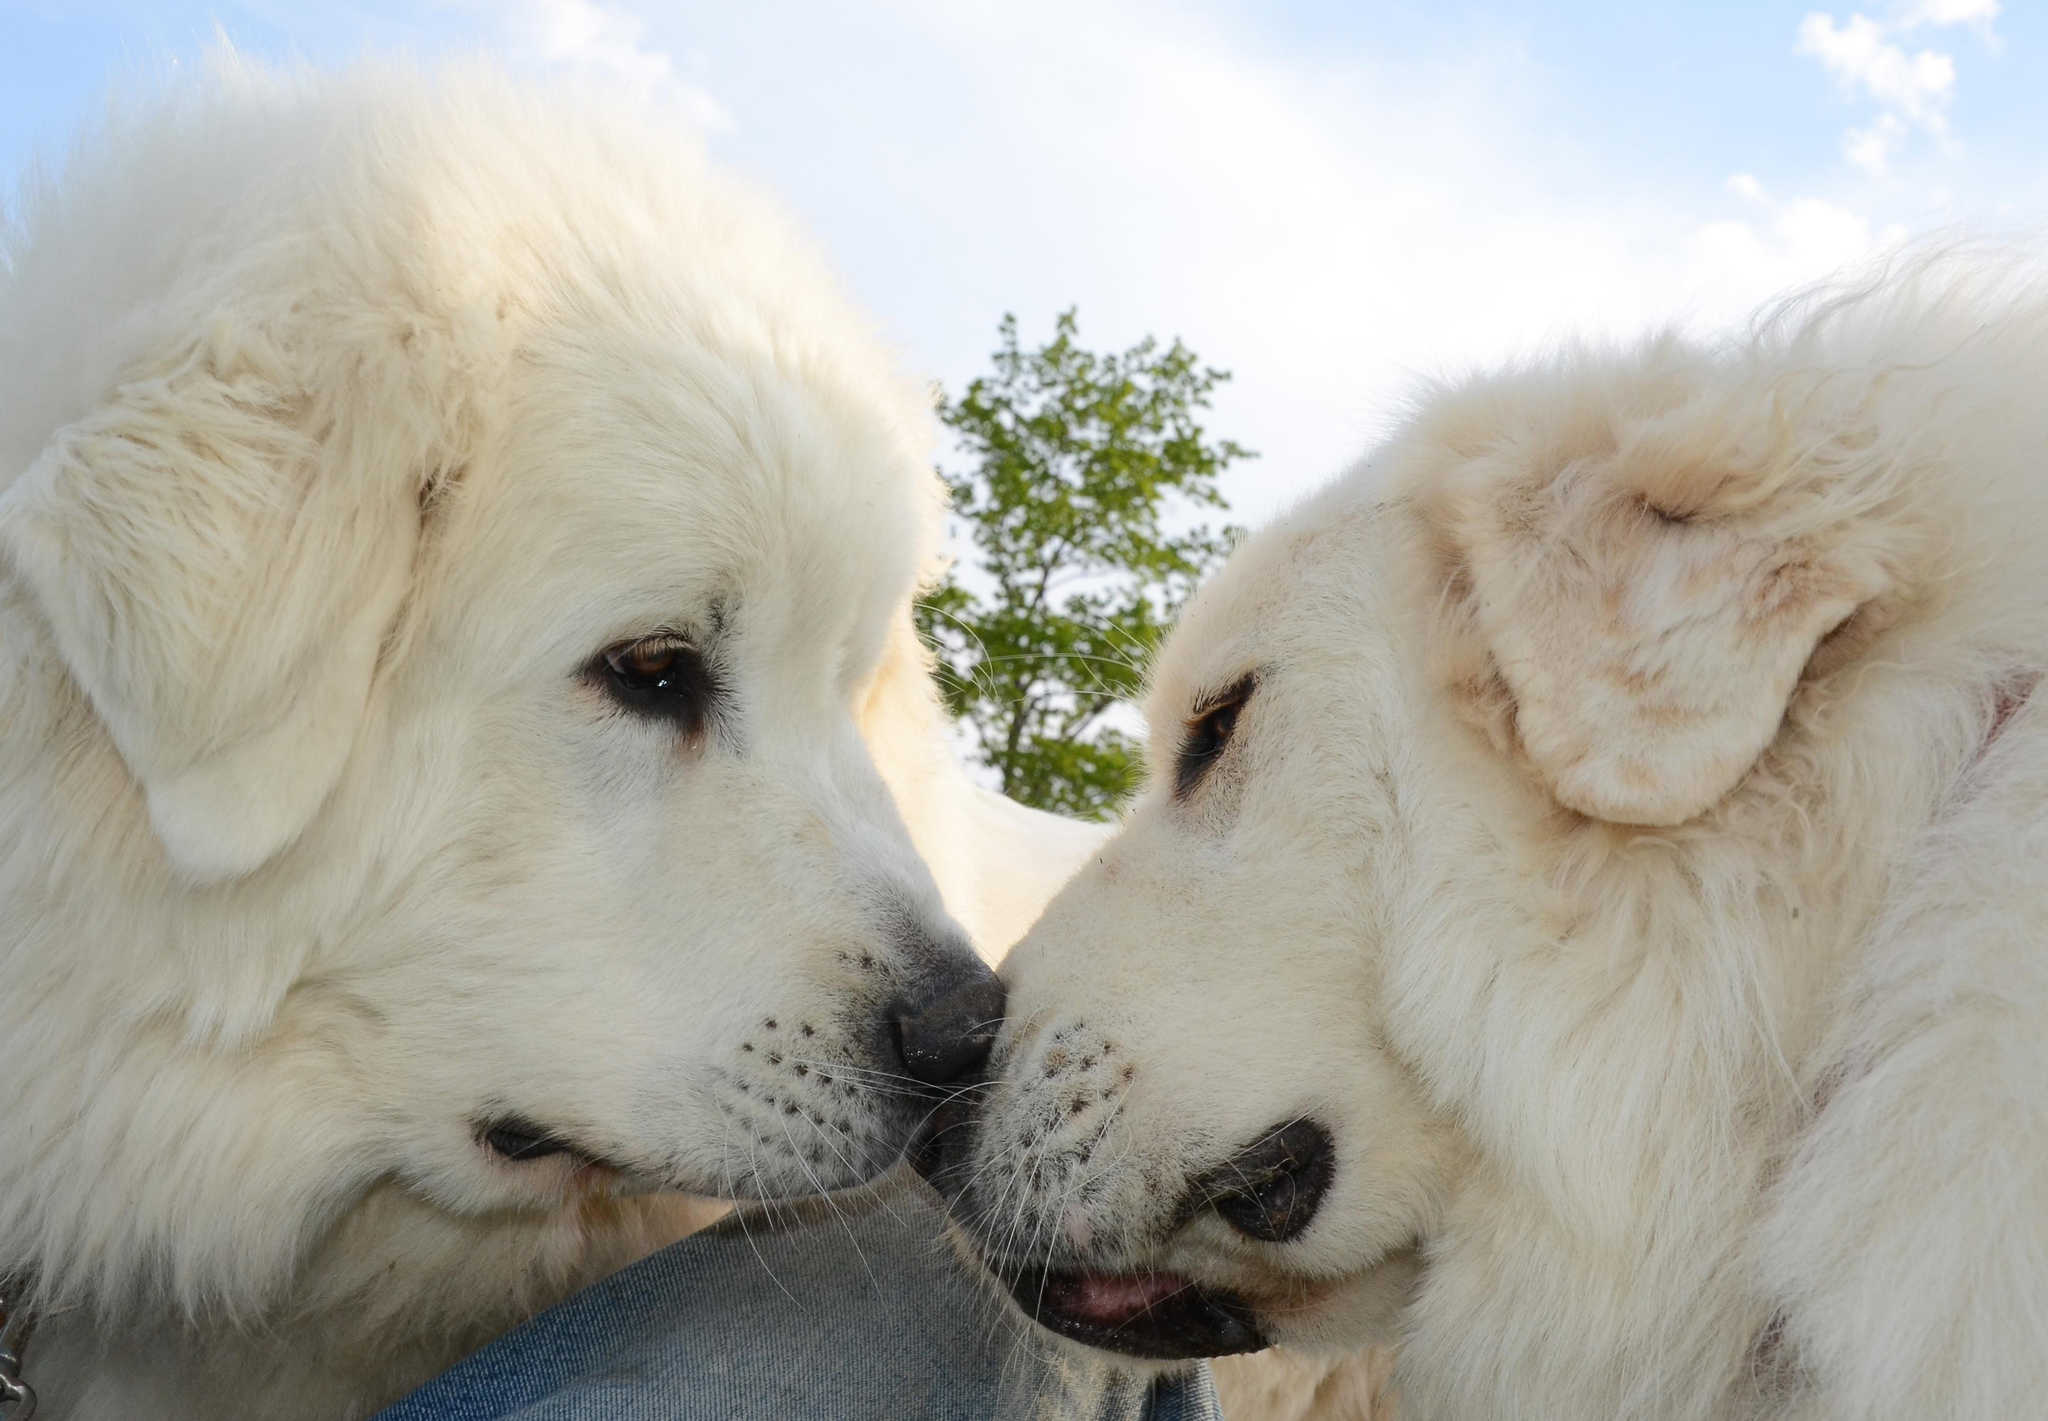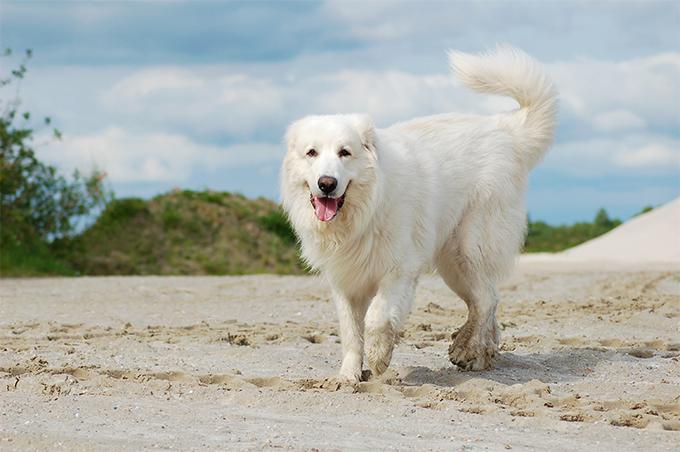The first image is the image on the left, the second image is the image on the right. Given the left and right images, does the statement "There are a total of three dogs, and there are more dogs in the left image." hold true? Answer yes or no. Yes. The first image is the image on the left, the second image is the image on the right. Given the left and right images, does the statement "Exactly three large white dogs are shown in outdoor settings." hold true? Answer yes or no. Yes. 